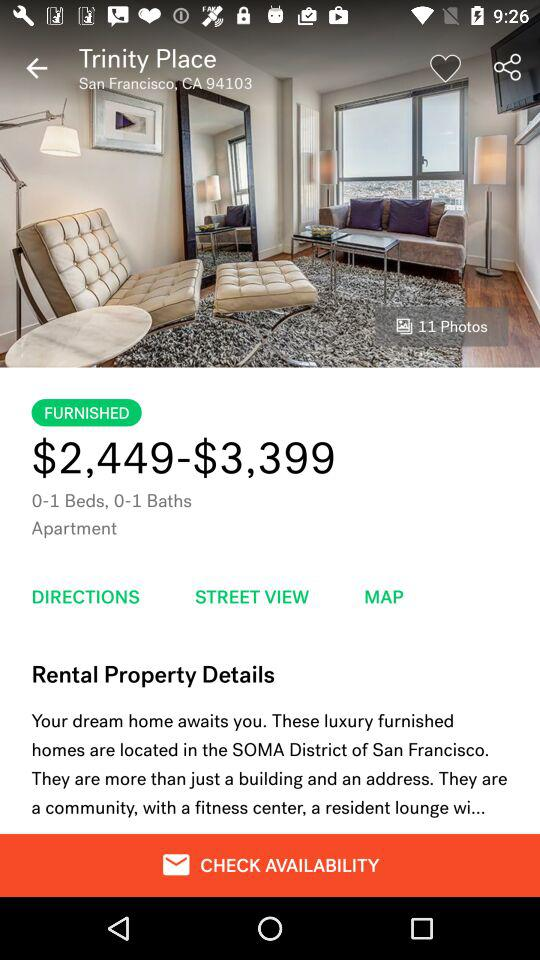What is the cost of the Trinity Place apartment? The cost ranges from $2,449 to $3,399. 